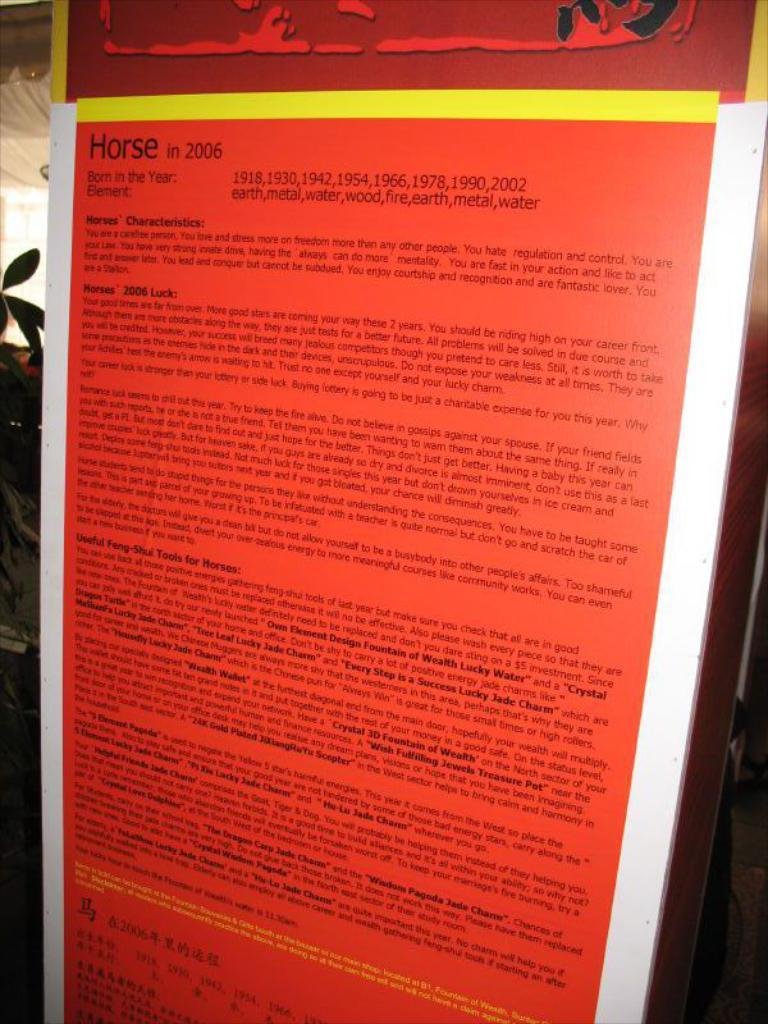Provide a one-sentence caption for the provided image. A plaque showing descriptions of the year of the horse and its characteristics. 